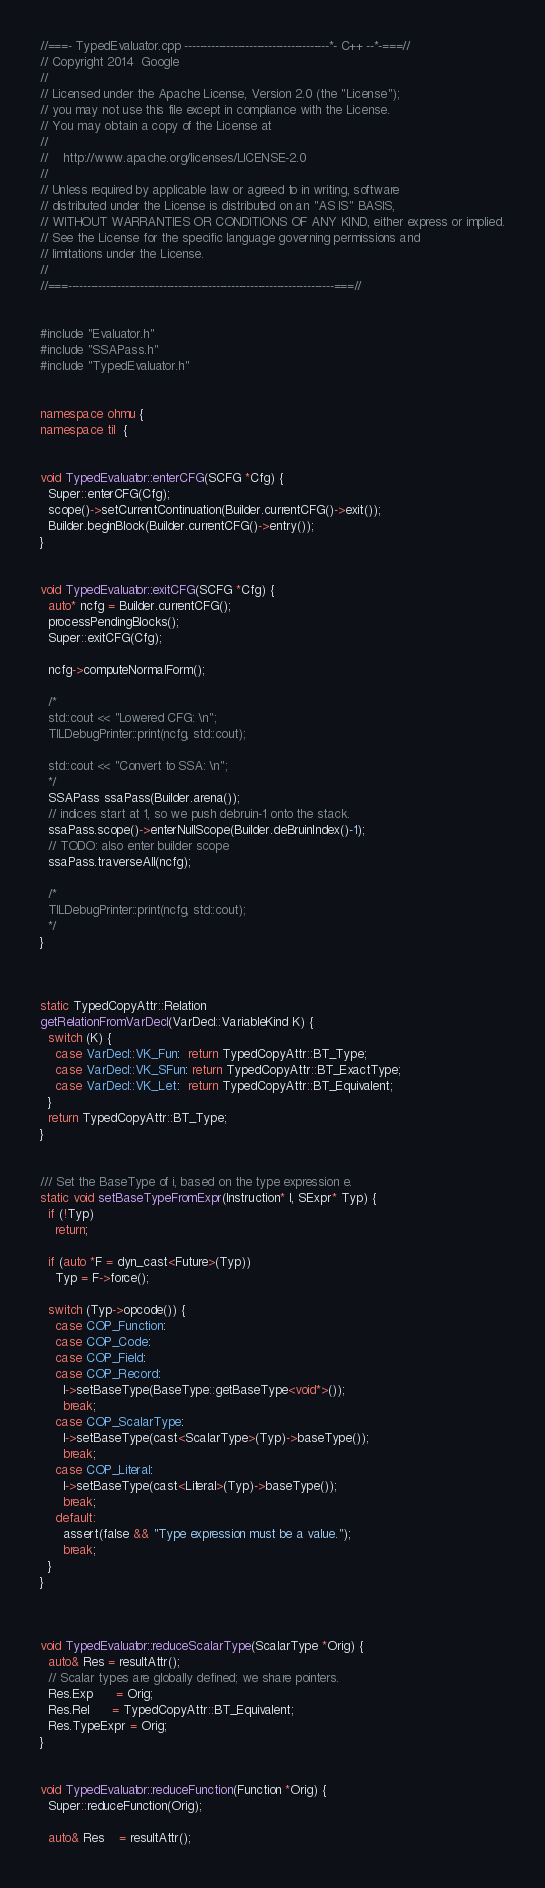Convert code to text. <code><loc_0><loc_0><loc_500><loc_500><_C++_>//===- TypedEvaluator.cpp --------------------------------------*- C++ --*-===//
// Copyright 2014  Google
//
// Licensed under the Apache License, Version 2.0 (the "License");
// you may not use this file except in compliance with the License.
// You may obtain a copy of the License at
//
//    http://www.apache.org/licenses/LICENSE-2.0
//
// Unless required by applicable law or agreed to in writing, software
// distributed under the License is distributed on an "AS IS" BASIS,
// WITHOUT WARRANTIES OR CONDITIONS OF ANY KIND, either express or implied.
// See the License for the specific language governing permissions and
// limitations under the License.
//
//===----------------------------------------------------------------------===//


#include "Evaluator.h"
#include "SSAPass.h"
#include "TypedEvaluator.h"


namespace ohmu {
namespace til  {


void TypedEvaluator::enterCFG(SCFG *Cfg) {
  Super::enterCFG(Cfg);
  scope()->setCurrentContinuation(Builder.currentCFG()->exit());
  Builder.beginBlock(Builder.currentCFG()->entry());
}


void TypedEvaluator::exitCFG(SCFG *Cfg) {
  auto* ncfg = Builder.currentCFG();
  processPendingBlocks();
  Super::exitCFG(Cfg);

  ncfg->computeNormalForm();

  /*
  std::cout << "Lowered CFG: \n";
  TILDebugPrinter::print(ncfg, std::cout);

  std::cout << "Convert to SSA: \n";
  */
  SSAPass ssaPass(Builder.arena());
  // indices start at 1, so we push debruin-1 onto the stack.
  ssaPass.scope()->enterNullScope(Builder.deBruinIndex()-1);
  // TODO: also enter builder scope
  ssaPass.traverseAll(ncfg);

  /*
  TILDebugPrinter::print(ncfg, std::cout);
  */
}



static TypedCopyAttr::Relation
getRelationFromVarDecl(VarDecl::VariableKind K) {
  switch (K) {
    case VarDecl::VK_Fun:  return TypedCopyAttr::BT_Type;
    case VarDecl::VK_SFun: return TypedCopyAttr::BT_ExactType;
    case VarDecl::VK_Let:  return TypedCopyAttr::BT_Equivalent;
  }
  return TypedCopyAttr::BT_Type;
}


/// Set the BaseType of i, based on the type expression e.
static void setBaseTypeFromExpr(Instruction* I, SExpr* Typ) {
  if (!Typ)
    return;

  if (auto *F = dyn_cast<Future>(Typ))
    Typ = F->force();

  switch (Typ->opcode()) {
    case COP_Function:
    case COP_Code:
    case COP_Field:
    case COP_Record:
      I->setBaseType(BaseType::getBaseType<void*>());
      break;
    case COP_ScalarType:
      I->setBaseType(cast<ScalarType>(Typ)->baseType());
      break;
    case COP_Literal:
      I->setBaseType(cast<Literal>(Typ)->baseType());
      break;
    default:
      assert(false && "Type expression must be a value.");
      break;
  }
}



void TypedEvaluator::reduceScalarType(ScalarType *Orig) {
  auto& Res = resultAttr();
  // Scalar types are globally defined; we share pointers.
  Res.Exp      = Orig;
  Res.Rel      = TypedCopyAttr::BT_Equivalent;
  Res.TypeExpr = Orig;
}


void TypedEvaluator::reduceFunction(Function *Orig) {
  Super::reduceFunction(Orig);

  auto& Res    = resultAttr();</code> 